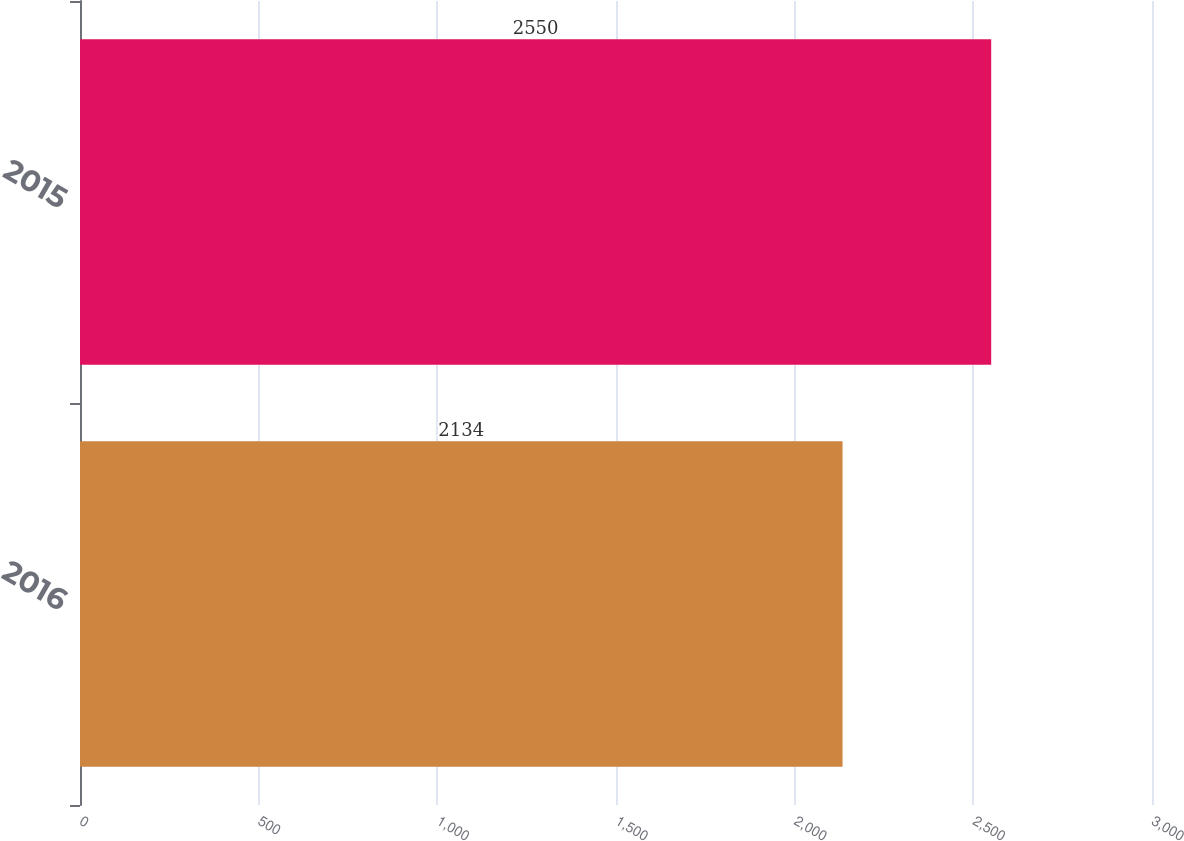Convert chart to OTSL. <chart><loc_0><loc_0><loc_500><loc_500><bar_chart><fcel>2016<fcel>2015<nl><fcel>2134<fcel>2550<nl></chart> 